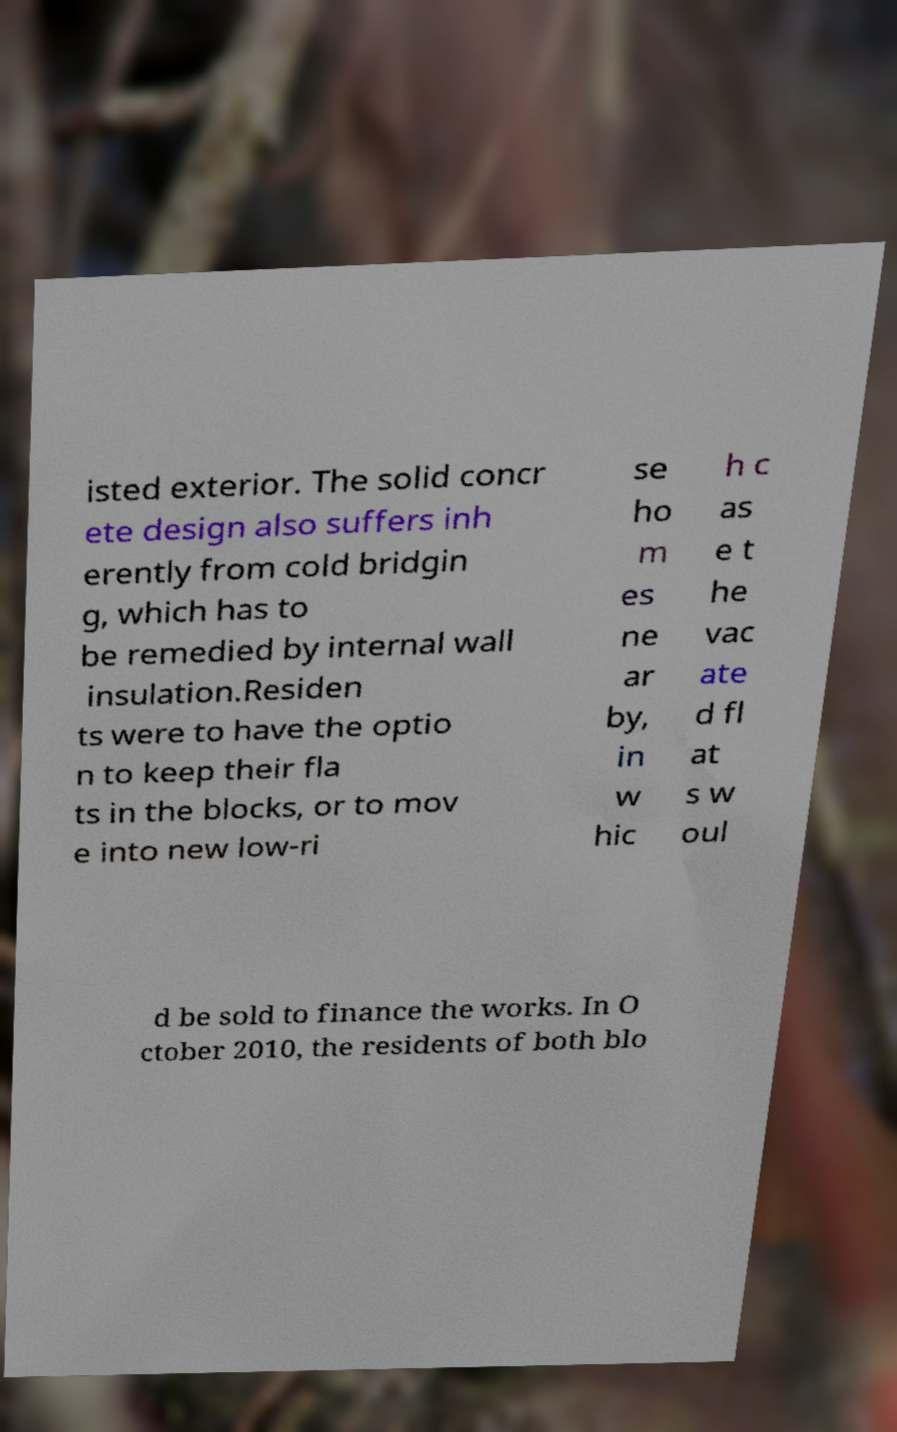Could you assist in decoding the text presented in this image and type it out clearly? isted exterior. The solid concr ete design also suffers inh erently from cold bridgin g, which has to be remedied by internal wall insulation.Residen ts were to have the optio n to keep their fla ts in the blocks, or to mov e into new low-ri se ho m es ne ar by, in w hic h c as e t he vac ate d fl at s w oul d be sold to finance the works. In O ctober 2010, the residents of both blo 